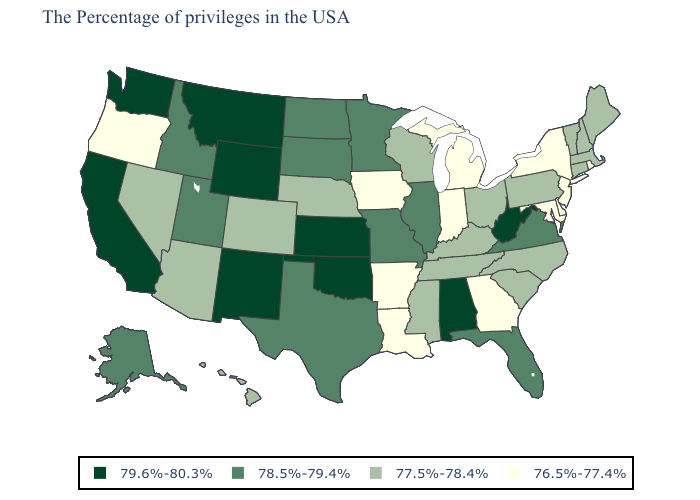Name the states that have a value in the range 78.5%-79.4%?
Short answer required. Virginia, Florida, Illinois, Missouri, Minnesota, Texas, South Dakota, North Dakota, Utah, Idaho, Alaska. Name the states that have a value in the range 78.5%-79.4%?
Give a very brief answer. Virginia, Florida, Illinois, Missouri, Minnesota, Texas, South Dakota, North Dakota, Utah, Idaho, Alaska. Does South Carolina have a lower value than Washington?
Keep it brief. Yes. Does Ohio have the lowest value in the MidWest?
Write a very short answer. No. Name the states that have a value in the range 77.5%-78.4%?
Quick response, please. Maine, Massachusetts, New Hampshire, Vermont, Connecticut, Pennsylvania, North Carolina, South Carolina, Ohio, Kentucky, Tennessee, Wisconsin, Mississippi, Nebraska, Colorado, Arizona, Nevada, Hawaii. Name the states that have a value in the range 77.5%-78.4%?
Concise answer only. Maine, Massachusetts, New Hampshire, Vermont, Connecticut, Pennsylvania, North Carolina, South Carolina, Ohio, Kentucky, Tennessee, Wisconsin, Mississippi, Nebraska, Colorado, Arizona, Nevada, Hawaii. Which states have the lowest value in the USA?
Give a very brief answer. Rhode Island, New York, New Jersey, Delaware, Maryland, Georgia, Michigan, Indiana, Louisiana, Arkansas, Iowa, Oregon. Name the states that have a value in the range 76.5%-77.4%?
Give a very brief answer. Rhode Island, New York, New Jersey, Delaware, Maryland, Georgia, Michigan, Indiana, Louisiana, Arkansas, Iowa, Oregon. What is the value of Montana?
Give a very brief answer. 79.6%-80.3%. What is the value of South Dakota?
Write a very short answer. 78.5%-79.4%. What is the value of Colorado?
Keep it brief. 77.5%-78.4%. What is the highest value in the USA?
Quick response, please. 79.6%-80.3%. Among the states that border Delaware , does Maryland have the lowest value?
Give a very brief answer. Yes. What is the value of Wyoming?
Give a very brief answer. 79.6%-80.3%. Does New Mexico have the same value as Wyoming?
Write a very short answer. Yes. 